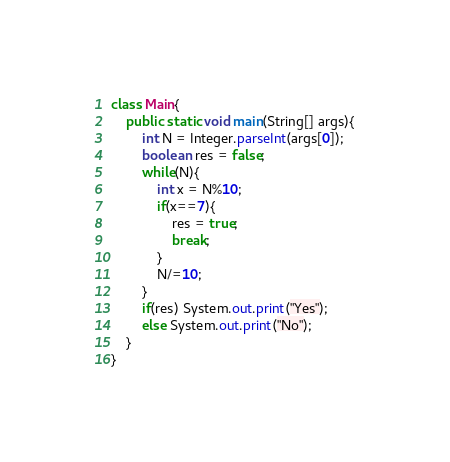Convert code to text. <code><loc_0><loc_0><loc_500><loc_500><_Java_>class Main{
	public static void main(String[] args){
    	int N = Integer.parseInt(args[0]);
      	boolean res = false;
      	while(N){
          	int x = N%10;
          	if(x==7){
            	res = true;
              	break;
            }
          	N/=10;
        }
      	if(res) System.out.print("Yes");
      	else System.out.print("No");
    }
}</code> 